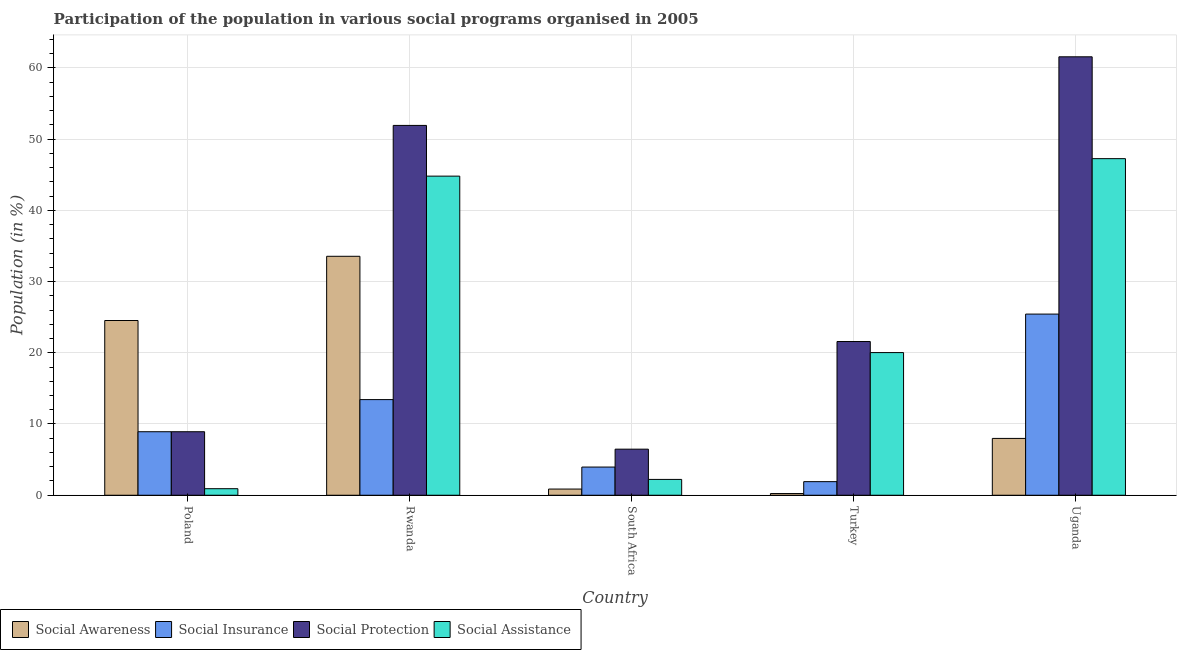Are the number of bars per tick equal to the number of legend labels?
Ensure brevity in your answer.  Yes. Are the number of bars on each tick of the X-axis equal?
Ensure brevity in your answer.  Yes. How many bars are there on the 3rd tick from the left?
Your answer should be compact. 4. How many bars are there on the 3rd tick from the right?
Give a very brief answer. 4. What is the participation of population in social assistance programs in Rwanda?
Provide a short and direct response. 44.79. Across all countries, what is the maximum participation of population in social protection programs?
Ensure brevity in your answer.  61.55. Across all countries, what is the minimum participation of population in social awareness programs?
Give a very brief answer. 0.24. In which country was the participation of population in social assistance programs maximum?
Your answer should be compact. Uganda. In which country was the participation of population in social protection programs minimum?
Provide a short and direct response. South Africa. What is the total participation of population in social insurance programs in the graph?
Your response must be concise. 53.63. What is the difference between the participation of population in social protection programs in Turkey and that in Uganda?
Offer a terse response. -39.97. What is the difference between the participation of population in social insurance programs in Uganda and the participation of population in social assistance programs in Rwanda?
Your response must be concise. -19.36. What is the average participation of population in social awareness programs per country?
Give a very brief answer. 13.43. What is the difference between the participation of population in social insurance programs and participation of population in social assistance programs in Turkey?
Offer a very short reply. -18.12. What is the ratio of the participation of population in social awareness programs in Rwanda to that in South Africa?
Your response must be concise. 38.67. What is the difference between the highest and the second highest participation of population in social insurance programs?
Offer a terse response. 12.01. What is the difference between the highest and the lowest participation of population in social awareness programs?
Offer a very short reply. 33.3. In how many countries, is the participation of population in social insurance programs greater than the average participation of population in social insurance programs taken over all countries?
Your answer should be very brief. 2. Is it the case that in every country, the sum of the participation of population in social protection programs and participation of population in social assistance programs is greater than the sum of participation of population in social insurance programs and participation of population in social awareness programs?
Your answer should be very brief. No. What does the 4th bar from the left in Uganda represents?
Offer a very short reply. Social Assistance. What does the 4th bar from the right in Turkey represents?
Offer a very short reply. Social Awareness. How many bars are there?
Offer a very short reply. 20. Are all the bars in the graph horizontal?
Your answer should be compact. No. What is the difference between two consecutive major ticks on the Y-axis?
Offer a terse response. 10. Are the values on the major ticks of Y-axis written in scientific E-notation?
Provide a short and direct response. No. Does the graph contain any zero values?
Your answer should be very brief. No. Does the graph contain grids?
Provide a short and direct response. Yes. Where does the legend appear in the graph?
Your response must be concise. Bottom left. How many legend labels are there?
Your answer should be very brief. 4. What is the title of the graph?
Your answer should be very brief. Participation of the population in various social programs organised in 2005. What is the label or title of the Y-axis?
Your response must be concise. Population (in %). What is the Population (in %) in Social Awareness in Poland?
Offer a very short reply. 24.53. What is the Population (in %) of Social Insurance in Poland?
Give a very brief answer. 8.91. What is the Population (in %) in Social Protection in Poland?
Your response must be concise. 8.91. What is the Population (in %) of Social Assistance in Poland?
Your response must be concise. 0.92. What is the Population (in %) in Social Awareness in Rwanda?
Provide a succinct answer. 33.54. What is the Population (in %) of Social Insurance in Rwanda?
Your answer should be very brief. 13.42. What is the Population (in %) in Social Protection in Rwanda?
Give a very brief answer. 51.91. What is the Population (in %) in Social Assistance in Rwanda?
Ensure brevity in your answer.  44.79. What is the Population (in %) of Social Awareness in South Africa?
Make the answer very short. 0.87. What is the Population (in %) in Social Insurance in South Africa?
Your answer should be compact. 3.96. What is the Population (in %) in Social Protection in South Africa?
Offer a very short reply. 6.47. What is the Population (in %) in Social Assistance in South Africa?
Keep it short and to the point. 2.22. What is the Population (in %) in Social Awareness in Turkey?
Offer a terse response. 0.24. What is the Population (in %) of Social Insurance in Turkey?
Keep it short and to the point. 1.91. What is the Population (in %) in Social Protection in Turkey?
Keep it short and to the point. 21.58. What is the Population (in %) of Social Assistance in Turkey?
Provide a succinct answer. 20.02. What is the Population (in %) of Social Awareness in Uganda?
Give a very brief answer. 7.98. What is the Population (in %) of Social Insurance in Uganda?
Keep it short and to the point. 25.43. What is the Population (in %) in Social Protection in Uganda?
Offer a very short reply. 61.55. What is the Population (in %) in Social Assistance in Uganda?
Your answer should be compact. 47.25. Across all countries, what is the maximum Population (in %) in Social Awareness?
Ensure brevity in your answer.  33.54. Across all countries, what is the maximum Population (in %) in Social Insurance?
Provide a short and direct response. 25.43. Across all countries, what is the maximum Population (in %) of Social Protection?
Make the answer very short. 61.55. Across all countries, what is the maximum Population (in %) of Social Assistance?
Provide a short and direct response. 47.25. Across all countries, what is the minimum Population (in %) in Social Awareness?
Your answer should be very brief. 0.24. Across all countries, what is the minimum Population (in %) of Social Insurance?
Give a very brief answer. 1.91. Across all countries, what is the minimum Population (in %) of Social Protection?
Make the answer very short. 6.47. Across all countries, what is the minimum Population (in %) of Social Assistance?
Ensure brevity in your answer.  0.92. What is the total Population (in %) in Social Awareness in the graph?
Your answer should be compact. 67.15. What is the total Population (in %) of Social Insurance in the graph?
Your response must be concise. 53.63. What is the total Population (in %) in Social Protection in the graph?
Your response must be concise. 150.42. What is the total Population (in %) of Social Assistance in the graph?
Ensure brevity in your answer.  115.2. What is the difference between the Population (in %) of Social Awareness in Poland and that in Rwanda?
Your answer should be compact. -9.02. What is the difference between the Population (in %) of Social Insurance in Poland and that in Rwanda?
Ensure brevity in your answer.  -4.51. What is the difference between the Population (in %) of Social Protection in Poland and that in Rwanda?
Your answer should be very brief. -43. What is the difference between the Population (in %) in Social Assistance in Poland and that in Rwanda?
Your answer should be very brief. -43.88. What is the difference between the Population (in %) in Social Awareness in Poland and that in South Africa?
Your answer should be very brief. 23.66. What is the difference between the Population (in %) in Social Insurance in Poland and that in South Africa?
Keep it short and to the point. 4.96. What is the difference between the Population (in %) in Social Protection in Poland and that in South Africa?
Give a very brief answer. 2.45. What is the difference between the Population (in %) of Social Assistance in Poland and that in South Africa?
Make the answer very short. -1.3. What is the difference between the Population (in %) in Social Awareness in Poland and that in Turkey?
Offer a terse response. 24.29. What is the difference between the Population (in %) of Social Insurance in Poland and that in Turkey?
Your response must be concise. 7.01. What is the difference between the Population (in %) in Social Protection in Poland and that in Turkey?
Ensure brevity in your answer.  -12.66. What is the difference between the Population (in %) of Social Assistance in Poland and that in Turkey?
Offer a terse response. -19.11. What is the difference between the Population (in %) of Social Awareness in Poland and that in Uganda?
Provide a short and direct response. 16.55. What is the difference between the Population (in %) of Social Insurance in Poland and that in Uganda?
Offer a very short reply. -16.51. What is the difference between the Population (in %) of Social Protection in Poland and that in Uganda?
Offer a very short reply. -52.63. What is the difference between the Population (in %) in Social Assistance in Poland and that in Uganda?
Offer a very short reply. -46.33. What is the difference between the Population (in %) in Social Awareness in Rwanda and that in South Africa?
Offer a terse response. 32.68. What is the difference between the Population (in %) in Social Insurance in Rwanda and that in South Africa?
Provide a succinct answer. 9.47. What is the difference between the Population (in %) in Social Protection in Rwanda and that in South Africa?
Offer a terse response. 45.45. What is the difference between the Population (in %) in Social Assistance in Rwanda and that in South Africa?
Offer a terse response. 42.57. What is the difference between the Population (in %) in Social Awareness in Rwanda and that in Turkey?
Your response must be concise. 33.3. What is the difference between the Population (in %) of Social Insurance in Rwanda and that in Turkey?
Your answer should be very brief. 11.52. What is the difference between the Population (in %) in Social Protection in Rwanda and that in Turkey?
Your answer should be compact. 30.34. What is the difference between the Population (in %) in Social Assistance in Rwanda and that in Turkey?
Provide a succinct answer. 24.77. What is the difference between the Population (in %) of Social Awareness in Rwanda and that in Uganda?
Provide a short and direct response. 25.57. What is the difference between the Population (in %) of Social Insurance in Rwanda and that in Uganda?
Your answer should be compact. -12.01. What is the difference between the Population (in %) in Social Protection in Rwanda and that in Uganda?
Provide a succinct answer. -9.63. What is the difference between the Population (in %) of Social Assistance in Rwanda and that in Uganda?
Your answer should be very brief. -2.45. What is the difference between the Population (in %) in Social Awareness in South Africa and that in Turkey?
Ensure brevity in your answer.  0.63. What is the difference between the Population (in %) in Social Insurance in South Africa and that in Turkey?
Your response must be concise. 2.05. What is the difference between the Population (in %) in Social Protection in South Africa and that in Turkey?
Give a very brief answer. -15.11. What is the difference between the Population (in %) of Social Assistance in South Africa and that in Turkey?
Provide a succinct answer. -17.8. What is the difference between the Population (in %) of Social Awareness in South Africa and that in Uganda?
Provide a succinct answer. -7.11. What is the difference between the Population (in %) of Social Insurance in South Africa and that in Uganda?
Offer a terse response. -21.47. What is the difference between the Population (in %) in Social Protection in South Africa and that in Uganda?
Make the answer very short. -55.08. What is the difference between the Population (in %) of Social Assistance in South Africa and that in Uganda?
Provide a succinct answer. -45.03. What is the difference between the Population (in %) in Social Awareness in Turkey and that in Uganda?
Offer a terse response. -7.74. What is the difference between the Population (in %) of Social Insurance in Turkey and that in Uganda?
Offer a terse response. -23.52. What is the difference between the Population (in %) of Social Protection in Turkey and that in Uganda?
Your answer should be compact. -39.97. What is the difference between the Population (in %) in Social Assistance in Turkey and that in Uganda?
Provide a short and direct response. -27.22. What is the difference between the Population (in %) in Social Awareness in Poland and the Population (in %) in Social Insurance in Rwanda?
Give a very brief answer. 11.1. What is the difference between the Population (in %) in Social Awareness in Poland and the Population (in %) in Social Protection in Rwanda?
Your response must be concise. -27.39. What is the difference between the Population (in %) of Social Awareness in Poland and the Population (in %) of Social Assistance in Rwanda?
Ensure brevity in your answer.  -20.27. What is the difference between the Population (in %) in Social Insurance in Poland and the Population (in %) in Social Protection in Rwanda?
Ensure brevity in your answer.  -43. What is the difference between the Population (in %) in Social Insurance in Poland and the Population (in %) in Social Assistance in Rwanda?
Provide a succinct answer. -35.88. What is the difference between the Population (in %) of Social Protection in Poland and the Population (in %) of Social Assistance in Rwanda?
Offer a terse response. -35.88. What is the difference between the Population (in %) in Social Awareness in Poland and the Population (in %) in Social Insurance in South Africa?
Offer a terse response. 20.57. What is the difference between the Population (in %) of Social Awareness in Poland and the Population (in %) of Social Protection in South Africa?
Ensure brevity in your answer.  18.06. What is the difference between the Population (in %) in Social Awareness in Poland and the Population (in %) in Social Assistance in South Africa?
Give a very brief answer. 22.31. What is the difference between the Population (in %) in Social Insurance in Poland and the Population (in %) in Social Protection in South Africa?
Your answer should be very brief. 2.45. What is the difference between the Population (in %) of Social Insurance in Poland and the Population (in %) of Social Assistance in South Africa?
Give a very brief answer. 6.69. What is the difference between the Population (in %) in Social Protection in Poland and the Population (in %) in Social Assistance in South Africa?
Ensure brevity in your answer.  6.69. What is the difference between the Population (in %) in Social Awareness in Poland and the Population (in %) in Social Insurance in Turkey?
Make the answer very short. 22.62. What is the difference between the Population (in %) of Social Awareness in Poland and the Population (in %) of Social Protection in Turkey?
Your response must be concise. 2.95. What is the difference between the Population (in %) in Social Awareness in Poland and the Population (in %) in Social Assistance in Turkey?
Your response must be concise. 4.5. What is the difference between the Population (in %) in Social Insurance in Poland and the Population (in %) in Social Protection in Turkey?
Your response must be concise. -12.66. What is the difference between the Population (in %) of Social Insurance in Poland and the Population (in %) of Social Assistance in Turkey?
Your answer should be compact. -11.11. What is the difference between the Population (in %) of Social Protection in Poland and the Population (in %) of Social Assistance in Turkey?
Provide a short and direct response. -11.11. What is the difference between the Population (in %) in Social Awareness in Poland and the Population (in %) in Social Insurance in Uganda?
Provide a succinct answer. -0.9. What is the difference between the Population (in %) in Social Awareness in Poland and the Population (in %) in Social Protection in Uganda?
Your answer should be very brief. -37.02. What is the difference between the Population (in %) of Social Awareness in Poland and the Population (in %) of Social Assistance in Uganda?
Give a very brief answer. -22.72. What is the difference between the Population (in %) of Social Insurance in Poland and the Population (in %) of Social Protection in Uganda?
Your response must be concise. -52.63. What is the difference between the Population (in %) of Social Insurance in Poland and the Population (in %) of Social Assistance in Uganda?
Offer a terse response. -38.33. What is the difference between the Population (in %) in Social Protection in Poland and the Population (in %) in Social Assistance in Uganda?
Ensure brevity in your answer.  -38.33. What is the difference between the Population (in %) in Social Awareness in Rwanda and the Population (in %) in Social Insurance in South Africa?
Your response must be concise. 29.59. What is the difference between the Population (in %) of Social Awareness in Rwanda and the Population (in %) of Social Protection in South Africa?
Offer a terse response. 27.07. What is the difference between the Population (in %) of Social Awareness in Rwanda and the Population (in %) of Social Assistance in South Africa?
Make the answer very short. 31.32. What is the difference between the Population (in %) in Social Insurance in Rwanda and the Population (in %) in Social Protection in South Africa?
Ensure brevity in your answer.  6.96. What is the difference between the Population (in %) in Social Insurance in Rwanda and the Population (in %) in Social Assistance in South Africa?
Offer a very short reply. 11.2. What is the difference between the Population (in %) of Social Protection in Rwanda and the Population (in %) of Social Assistance in South Africa?
Offer a terse response. 49.69. What is the difference between the Population (in %) of Social Awareness in Rwanda and the Population (in %) of Social Insurance in Turkey?
Give a very brief answer. 31.64. What is the difference between the Population (in %) in Social Awareness in Rwanda and the Population (in %) in Social Protection in Turkey?
Offer a terse response. 11.96. What is the difference between the Population (in %) of Social Awareness in Rwanda and the Population (in %) of Social Assistance in Turkey?
Your response must be concise. 13.52. What is the difference between the Population (in %) of Social Insurance in Rwanda and the Population (in %) of Social Protection in Turkey?
Keep it short and to the point. -8.15. What is the difference between the Population (in %) in Social Insurance in Rwanda and the Population (in %) in Social Assistance in Turkey?
Provide a succinct answer. -6.6. What is the difference between the Population (in %) of Social Protection in Rwanda and the Population (in %) of Social Assistance in Turkey?
Ensure brevity in your answer.  31.89. What is the difference between the Population (in %) in Social Awareness in Rwanda and the Population (in %) in Social Insurance in Uganda?
Make the answer very short. 8.11. What is the difference between the Population (in %) of Social Awareness in Rwanda and the Population (in %) of Social Protection in Uganda?
Your answer should be compact. -28. What is the difference between the Population (in %) of Social Awareness in Rwanda and the Population (in %) of Social Assistance in Uganda?
Your answer should be compact. -13.71. What is the difference between the Population (in %) in Social Insurance in Rwanda and the Population (in %) in Social Protection in Uganda?
Keep it short and to the point. -48.12. What is the difference between the Population (in %) of Social Insurance in Rwanda and the Population (in %) of Social Assistance in Uganda?
Your answer should be compact. -33.82. What is the difference between the Population (in %) in Social Protection in Rwanda and the Population (in %) in Social Assistance in Uganda?
Provide a succinct answer. 4.67. What is the difference between the Population (in %) of Social Awareness in South Africa and the Population (in %) of Social Insurance in Turkey?
Keep it short and to the point. -1.04. What is the difference between the Population (in %) of Social Awareness in South Africa and the Population (in %) of Social Protection in Turkey?
Keep it short and to the point. -20.71. What is the difference between the Population (in %) in Social Awareness in South Africa and the Population (in %) in Social Assistance in Turkey?
Keep it short and to the point. -19.16. What is the difference between the Population (in %) of Social Insurance in South Africa and the Population (in %) of Social Protection in Turkey?
Give a very brief answer. -17.62. What is the difference between the Population (in %) of Social Insurance in South Africa and the Population (in %) of Social Assistance in Turkey?
Offer a terse response. -16.07. What is the difference between the Population (in %) of Social Protection in South Africa and the Population (in %) of Social Assistance in Turkey?
Give a very brief answer. -13.56. What is the difference between the Population (in %) in Social Awareness in South Africa and the Population (in %) in Social Insurance in Uganda?
Your response must be concise. -24.56. What is the difference between the Population (in %) in Social Awareness in South Africa and the Population (in %) in Social Protection in Uganda?
Provide a short and direct response. -60.68. What is the difference between the Population (in %) in Social Awareness in South Africa and the Population (in %) in Social Assistance in Uganda?
Give a very brief answer. -46.38. What is the difference between the Population (in %) in Social Insurance in South Africa and the Population (in %) in Social Protection in Uganda?
Provide a short and direct response. -57.59. What is the difference between the Population (in %) in Social Insurance in South Africa and the Population (in %) in Social Assistance in Uganda?
Make the answer very short. -43.29. What is the difference between the Population (in %) of Social Protection in South Africa and the Population (in %) of Social Assistance in Uganda?
Keep it short and to the point. -40.78. What is the difference between the Population (in %) of Social Awareness in Turkey and the Population (in %) of Social Insurance in Uganda?
Make the answer very short. -25.19. What is the difference between the Population (in %) in Social Awareness in Turkey and the Population (in %) in Social Protection in Uganda?
Your response must be concise. -61.31. What is the difference between the Population (in %) of Social Awareness in Turkey and the Population (in %) of Social Assistance in Uganda?
Make the answer very short. -47.01. What is the difference between the Population (in %) in Social Insurance in Turkey and the Population (in %) in Social Protection in Uganda?
Your response must be concise. -59.64. What is the difference between the Population (in %) of Social Insurance in Turkey and the Population (in %) of Social Assistance in Uganda?
Keep it short and to the point. -45.34. What is the difference between the Population (in %) of Social Protection in Turkey and the Population (in %) of Social Assistance in Uganda?
Give a very brief answer. -25.67. What is the average Population (in %) of Social Awareness per country?
Make the answer very short. 13.43. What is the average Population (in %) of Social Insurance per country?
Your answer should be very brief. 10.73. What is the average Population (in %) of Social Protection per country?
Your answer should be compact. 30.08. What is the average Population (in %) of Social Assistance per country?
Keep it short and to the point. 23.04. What is the difference between the Population (in %) of Social Awareness and Population (in %) of Social Insurance in Poland?
Give a very brief answer. 15.61. What is the difference between the Population (in %) of Social Awareness and Population (in %) of Social Protection in Poland?
Give a very brief answer. 15.61. What is the difference between the Population (in %) in Social Awareness and Population (in %) in Social Assistance in Poland?
Ensure brevity in your answer.  23.61. What is the difference between the Population (in %) of Social Insurance and Population (in %) of Social Protection in Poland?
Your response must be concise. 0. What is the difference between the Population (in %) in Social Insurance and Population (in %) in Social Assistance in Poland?
Your answer should be compact. 8. What is the difference between the Population (in %) in Social Protection and Population (in %) in Social Assistance in Poland?
Make the answer very short. 8. What is the difference between the Population (in %) of Social Awareness and Population (in %) of Social Insurance in Rwanda?
Make the answer very short. 20.12. What is the difference between the Population (in %) of Social Awareness and Population (in %) of Social Protection in Rwanda?
Make the answer very short. -18.37. What is the difference between the Population (in %) of Social Awareness and Population (in %) of Social Assistance in Rwanda?
Ensure brevity in your answer.  -11.25. What is the difference between the Population (in %) of Social Insurance and Population (in %) of Social Protection in Rwanda?
Offer a terse response. -38.49. What is the difference between the Population (in %) in Social Insurance and Population (in %) in Social Assistance in Rwanda?
Offer a very short reply. -31.37. What is the difference between the Population (in %) of Social Protection and Population (in %) of Social Assistance in Rwanda?
Offer a terse response. 7.12. What is the difference between the Population (in %) in Social Awareness and Population (in %) in Social Insurance in South Africa?
Keep it short and to the point. -3.09. What is the difference between the Population (in %) of Social Awareness and Population (in %) of Social Protection in South Africa?
Offer a terse response. -5.6. What is the difference between the Population (in %) of Social Awareness and Population (in %) of Social Assistance in South Africa?
Provide a succinct answer. -1.35. What is the difference between the Population (in %) in Social Insurance and Population (in %) in Social Protection in South Africa?
Offer a very short reply. -2.51. What is the difference between the Population (in %) of Social Insurance and Population (in %) of Social Assistance in South Africa?
Your answer should be compact. 1.74. What is the difference between the Population (in %) of Social Protection and Population (in %) of Social Assistance in South Africa?
Offer a very short reply. 4.25. What is the difference between the Population (in %) of Social Awareness and Population (in %) of Social Insurance in Turkey?
Offer a very short reply. -1.67. What is the difference between the Population (in %) of Social Awareness and Population (in %) of Social Protection in Turkey?
Your response must be concise. -21.34. What is the difference between the Population (in %) in Social Awareness and Population (in %) in Social Assistance in Turkey?
Give a very brief answer. -19.79. What is the difference between the Population (in %) in Social Insurance and Population (in %) in Social Protection in Turkey?
Give a very brief answer. -19.67. What is the difference between the Population (in %) of Social Insurance and Population (in %) of Social Assistance in Turkey?
Your answer should be compact. -18.12. What is the difference between the Population (in %) of Social Protection and Population (in %) of Social Assistance in Turkey?
Give a very brief answer. 1.55. What is the difference between the Population (in %) of Social Awareness and Population (in %) of Social Insurance in Uganda?
Make the answer very short. -17.45. What is the difference between the Population (in %) in Social Awareness and Population (in %) in Social Protection in Uganda?
Your response must be concise. -53.57. What is the difference between the Population (in %) of Social Awareness and Population (in %) of Social Assistance in Uganda?
Your answer should be very brief. -39.27. What is the difference between the Population (in %) of Social Insurance and Population (in %) of Social Protection in Uganda?
Provide a short and direct response. -36.12. What is the difference between the Population (in %) in Social Insurance and Population (in %) in Social Assistance in Uganda?
Ensure brevity in your answer.  -21.82. What is the difference between the Population (in %) of Social Protection and Population (in %) of Social Assistance in Uganda?
Ensure brevity in your answer.  14.3. What is the ratio of the Population (in %) in Social Awareness in Poland to that in Rwanda?
Provide a succinct answer. 0.73. What is the ratio of the Population (in %) of Social Insurance in Poland to that in Rwanda?
Offer a terse response. 0.66. What is the ratio of the Population (in %) in Social Protection in Poland to that in Rwanda?
Ensure brevity in your answer.  0.17. What is the ratio of the Population (in %) in Social Assistance in Poland to that in Rwanda?
Ensure brevity in your answer.  0.02. What is the ratio of the Population (in %) in Social Awareness in Poland to that in South Africa?
Offer a very short reply. 28.28. What is the ratio of the Population (in %) of Social Insurance in Poland to that in South Africa?
Provide a succinct answer. 2.25. What is the ratio of the Population (in %) of Social Protection in Poland to that in South Africa?
Offer a very short reply. 1.38. What is the ratio of the Population (in %) of Social Assistance in Poland to that in South Africa?
Your response must be concise. 0.41. What is the ratio of the Population (in %) in Social Awareness in Poland to that in Turkey?
Give a very brief answer. 102.92. What is the ratio of the Population (in %) in Social Insurance in Poland to that in Turkey?
Offer a very short reply. 4.67. What is the ratio of the Population (in %) in Social Protection in Poland to that in Turkey?
Offer a very short reply. 0.41. What is the ratio of the Population (in %) of Social Assistance in Poland to that in Turkey?
Offer a terse response. 0.05. What is the ratio of the Population (in %) of Social Awareness in Poland to that in Uganda?
Your answer should be very brief. 3.07. What is the ratio of the Population (in %) of Social Insurance in Poland to that in Uganda?
Offer a very short reply. 0.35. What is the ratio of the Population (in %) in Social Protection in Poland to that in Uganda?
Offer a very short reply. 0.14. What is the ratio of the Population (in %) of Social Assistance in Poland to that in Uganda?
Provide a succinct answer. 0.02. What is the ratio of the Population (in %) in Social Awareness in Rwanda to that in South Africa?
Provide a short and direct response. 38.67. What is the ratio of the Population (in %) of Social Insurance in Rwanda to that in South Africa?
Provide a succinct answer. 3.39. What is the ratio of the Population (in %) of Social Protection in Rwanda to that in South Africa?
Ensure brevity in your answer.  8.03. What is the ratio of the Population (in %) of Social Assistance in Rwanda to that in South Africa?
Your answer should be compact. 20.17. What is the ratio of the Population (in %) of Social Awareness in Rwanda to that in Turkey?
Keep it short and to the point. 140.75. What is the ratio of the Population (in %) of Social Insurance in Rwanda to that in Turkey?
Provide a short and direct response. 7.04. What is the ratio of the Population (in %) in Social Protection in Rwanda to that in Turkey?
Make the answer very short. 2.41. What is the ratio of the Population (in %) in Social Assistance in Rwanda to that in Turkey?
Your response must be concise. 2.24. What is the ratio of the Population (in %) in Social Awareness in Rwanda to that in Uganda?
Provide a succinct answer. 4.21. What is the ratio of the Population (in %) in Social Insurance in Rwanda to that in Uganda?
Keep it short and to the point. 0.53. What is the ratio of the Population (in %) in Social Protection in Rwanda to that in Uganda?
Your response must be concise. 0.84. What is the ratio of the Population (in %) of Social Assistance in Rwanda to that in Uganda?
Offer a terse response. 0.95. What is the ratio of the Population (in %) of Social Awareness in South Africa to that in Turkey?
Your answer should be compact. 3.64. What is the ratio of the Population (in %) in Social Insurance in South Africa to that in Turkey?
Your answer should be compact. 2.07. What is the ratio of the Population (in %) of Social Protection in South Africa to that in Turkey?
Ensure brevity in your answer.  0.3. What is the ratio of the Population (in %) of Social Assistance in South Africa to that in Turkey?
Give a very brief answer. 0.11. What is the ratio of the Population (in %) of Social Awareness in South Africa to that in Uganda?
Ensure brevity in your answer.  0.11. What is the ratio of the Population (in %) of Social Insurance in South Africa to that in Uganda?
Keep it short and to the point. 0.16. What is the ratio of the Population (in %) of Social Protection in South Africa to that in Uganda?
Your answer should be very brief. 0.11. What is the ratio of the Population (in %) of Social Assistance in South Africa to that in Uganda?
Ensure brevity in your answer.  0.05. What is the ratio of the Population (in %) in Social Awareness in Turkey to that in Uganda?
Offer a very short reply. 0.03. What is the ratio of the Population (in %) in Social Insurance in Turkey to that in Uganda?
Keep it short and to the point. 0.07. What is the ratio of the Population (in %) of Social Protection in Turkey to that in Uganda?
Provide a succinct answer. 0.35. What is the ratio of the Population (in %) of Social Assistance in Turkey to that in Uganda?
Your answer should be very brief. 0.42. What is the difference between the highest and the second highest Population (in %) of Social Awareness?
Your response must be concise. 9.02. What is the difference between the highest and the second highest Population (in %) of Social Insurance?
Provide a short and direct response. 12.01. What is the difference between the highest and the second highest Population (in %) in Social Protection?
Make the answer very short. 9.63. What is the difference between the highest and the second highest Population (in %) in Social Assistance?
Offer a very short reply. 2.45. What is the difference between the highest and the lowest Population (in %) of Social Awareness?
Offer a terse response. 33.3. What is the difference between the highest and the lowest Population (in %) in Social Insurance?
Ensure brevity in your answer.  23.52. What is the difference between the highest and the lowest Population (in %) in Social Protection?
Your answer should be very brief. 55.08. What is the difference between the highest and the lowest Population (in %) in Social Assistance?
Your answer should be very brief. 46.33. 